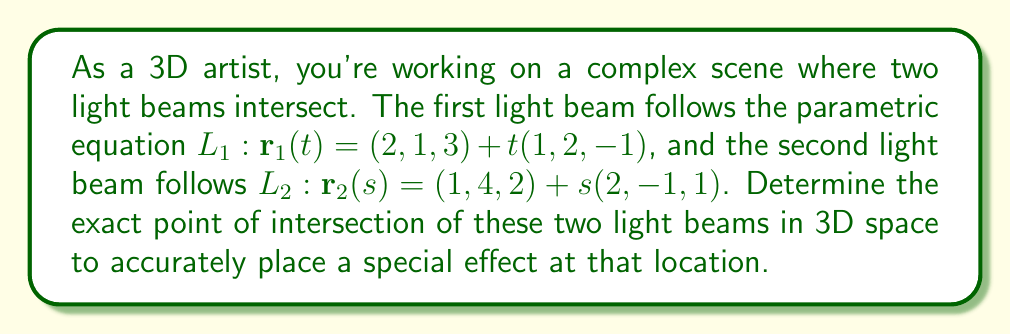Teach me how to tackle this problem. To find the intersection point of two lines in 3D space, we need to solve the equation:

$$\mathbf{r}_1(t) = \mathbf{r}_2(s)$$

This gives us three equations:

1) $2 + t = 1 + 2s$
2) $1 + 2t = 4 - s$
3) $3 - t = 2 + s$

From equation 1:
$$t = -1 + 2s \quad (4)$$

Substituting (4) into equation 2:
$$1 + 2(-1 + 2s) = 4 - s$$
$$1 - 2 + 4s = 4 - s$$
$$4s + s = 5$$
$$5s = 5$$
$$s = 1$$

Substituting $s = 1$ into (4):
$$t = -1 + 2(1) = 1$$

We can verify this solution satisfies equation 3:
$$3 - 1 = 2 + 1$$
$$2 = 3 \quad \text{(True)}$$

Now that we have $t = 1$ and $s = 1$, we can find the intersection point by substituting either value into its respective parametric equation. Let's use $L_1$:

$$\mathbf{r}_1(1) = (2, 1, 3) + 1(1, 2, -1)$$
$$= (2, 1, 3) + (1, 2, -1)$$
$$= (3, 3, 2)$$
Answer: The light beams intersect at the point $(3, 3, 2)$. 